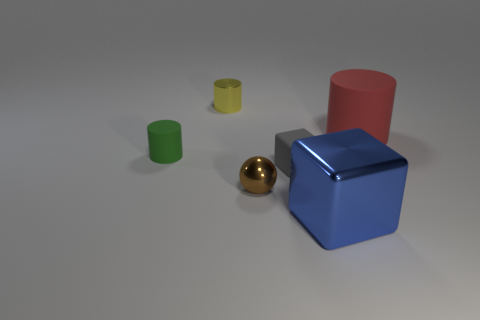If the golden sphere was twice as large, would it be bigger than the blue cube? If the golden sphere's size was doubled, it would appear larger but determining if it would be bigger than the blue cube is difficult without exact measurements. Visually, however, it might appear to have a greater volume due to its spherical shape. 